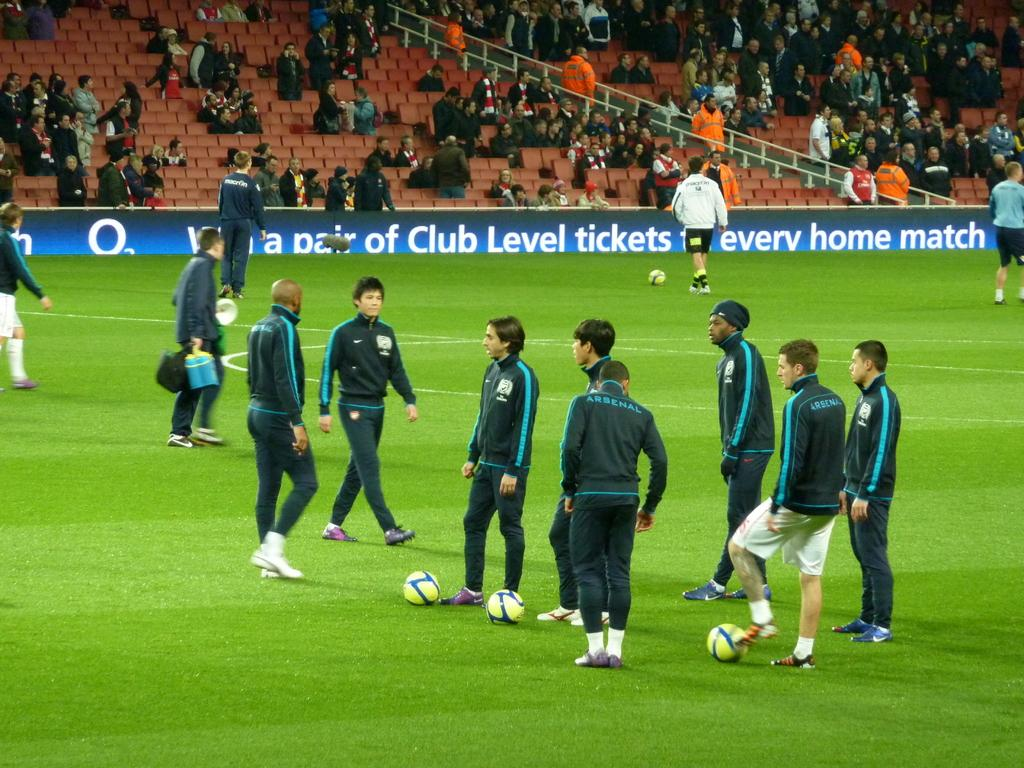What are the main subjects in the image? There are football players in the image. Where are the football players located? The football players are standing in a playground. What else can be seen on the ground in the image? There are balls on the ground in the image. What can be seen in the background of the image? There is an audience in the backdrop of the image. How are the members of the audience positioned? The audience is sitting in chairs. What day of the week is depicted in the image? The day of the week is not depicted in the image; it only shows football players, a playground, balls, and an audience. How many brothers are present among the football players in the image? There is no information about the number of brothers among the football players in the image. 